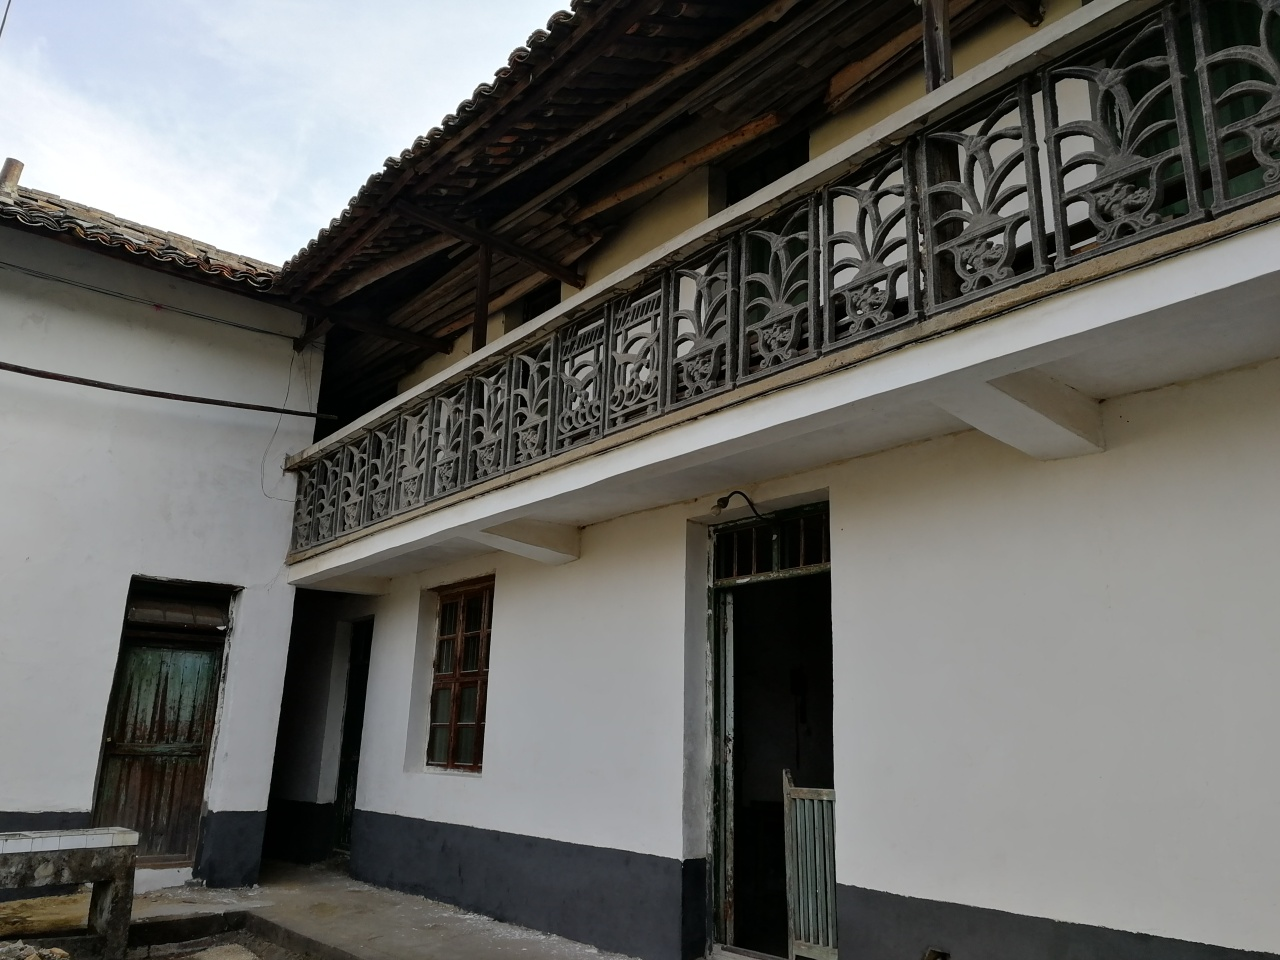What potential renovations could be done to preserve this building? Considering the visible wear on the building, restoration efforts could include repainting the exterior to preserve the building's facade, repairing the balcony to ensure safety while maintaining its historical design, and replacing any broken tiles on the roof. It would be essential to use materials and techniques in line with the building’s age and style to preserve its historical integrity. 